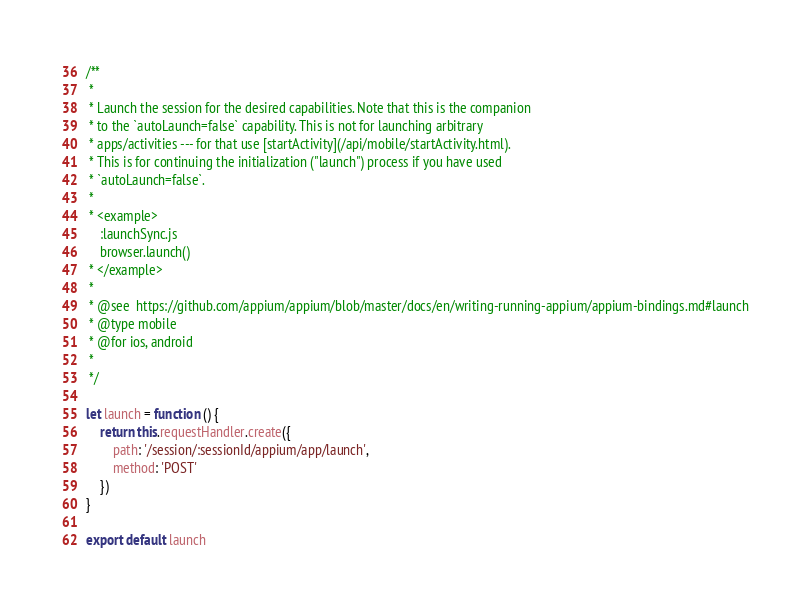Convert code to text. <code><loc_0><loc_0><loc_500><loc_500><_JavaScript_>/**
 *
 * Launch the session for the desired capabilities. Note that this is the companion
 * to the `autoLaunch=false` capability. This is not for launching arbitrary
 * apps/activities --- for that use [startActivity](/api/mobile/startActivity.html).
 * This is for continuing the initialization ("launch") process if you have used
 * `autoLaunch=false`.
 *
 * <example>
    :launchSync.js
    browser.launch()
 * </example>
 *
 * @see  https://github.com/appium/appium/blob/master/docs/en/writing-running-appium/appium-bindings.md#launch
 * @type mobile
 * @for ios, android
 *
 */

let launch = function () {
    return this.requestHandler.create({
        path: '/session/:sessionId/appium/app/launch',
        method: 'POST'
    })
}

export default launch
</code> 